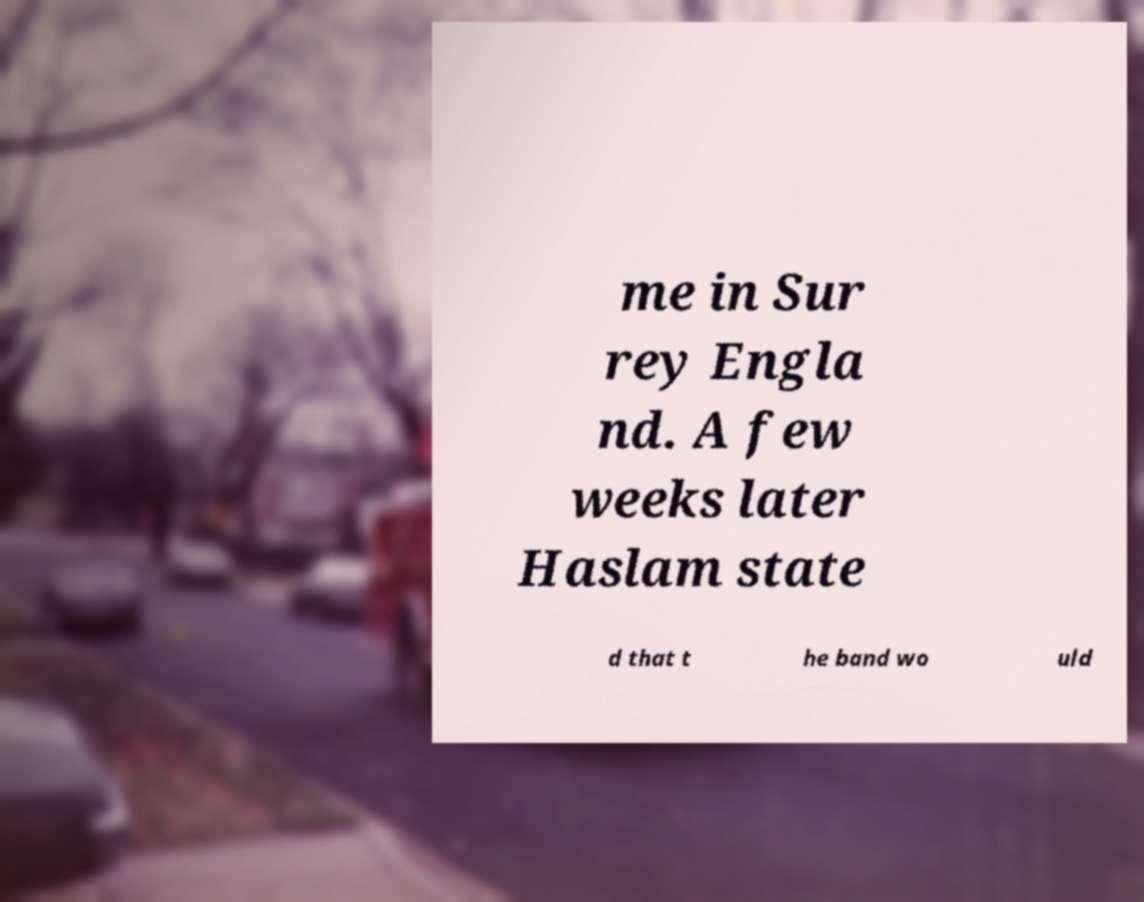What messages or text are displayed in this image? I need them in a readable, typed format. me in Sur rey Engla nd. A few weeks later Haslam state d that t he band wo uld 